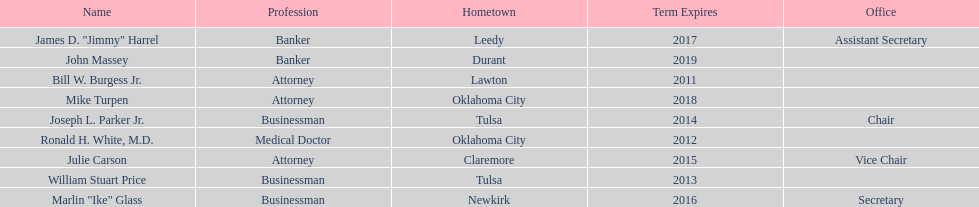What is the total amount of current state regents who are bankers? 2. 